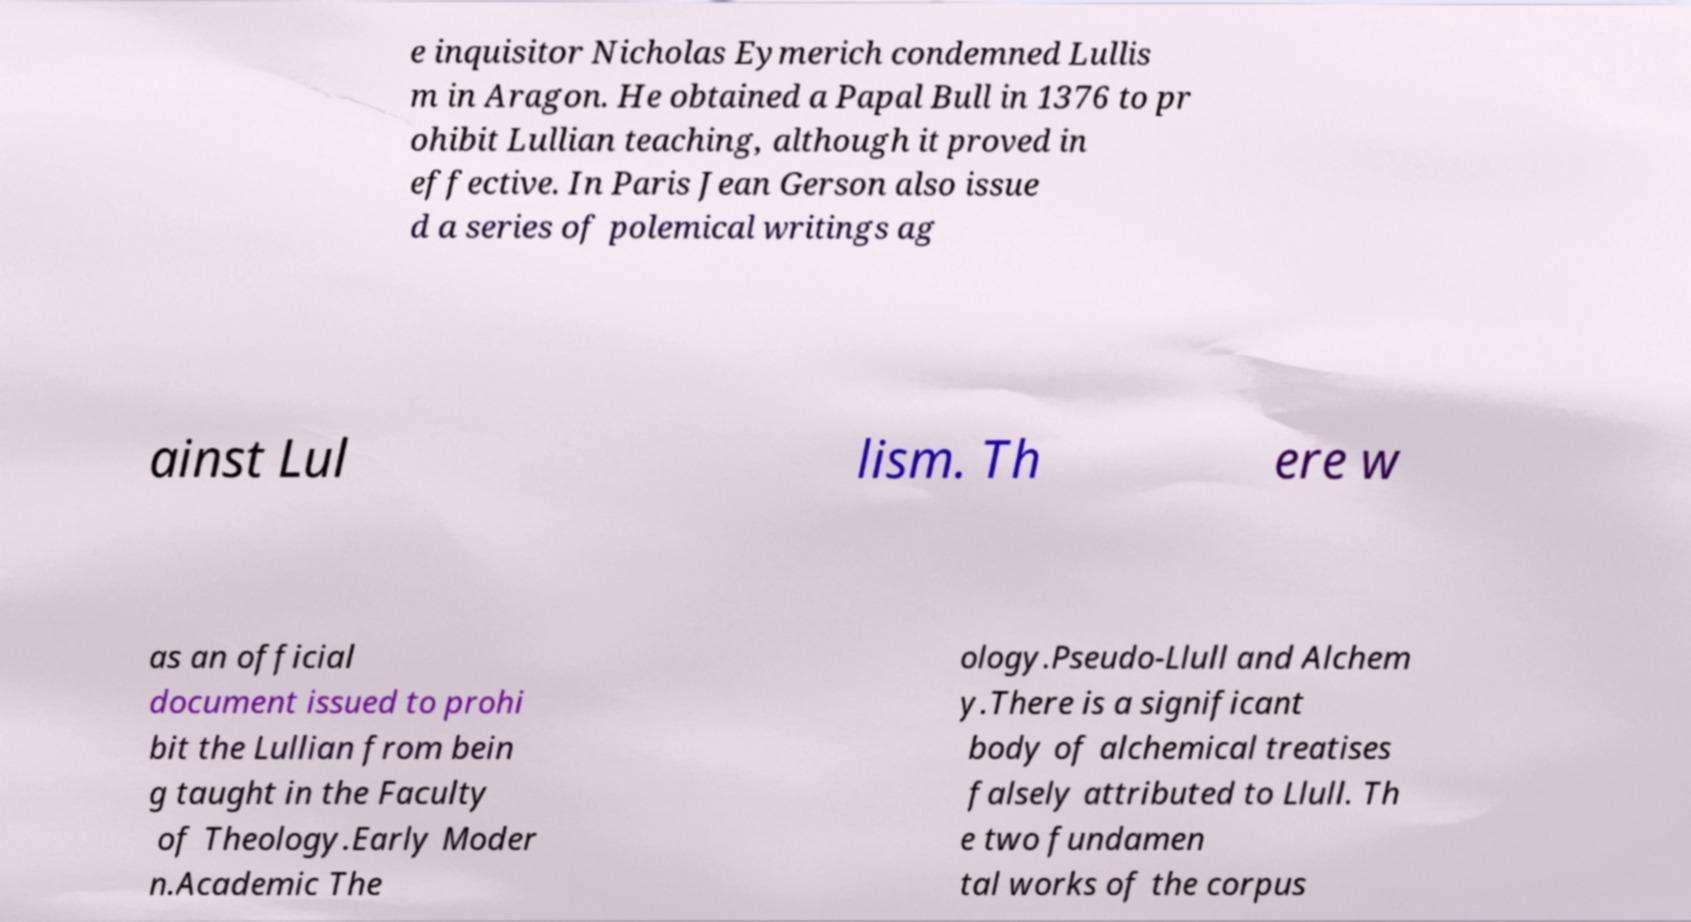For documentation purposes, I need the text within this image transcribed. Could you provide that? e inquisitor Nicholas Eymerich condemned Lullis m in Aragon. He obtained a Papal Bull in 1376 to pr ohibit Lullian teaching, although it proved in effective. In Paris Jean Gerson also issue d a series of polemical writings ag ainst Lul lism. Th ere w as an official document issued to prohi bit the Lullian from bein g taught in the Faculty of Theology.Early Moder n.Academic The ology.Pseudo-Llull and Alchem y.There is a significant body of alchemical treatises falsely attributed to Llull. Th e two fundamen tal works of the corpus 